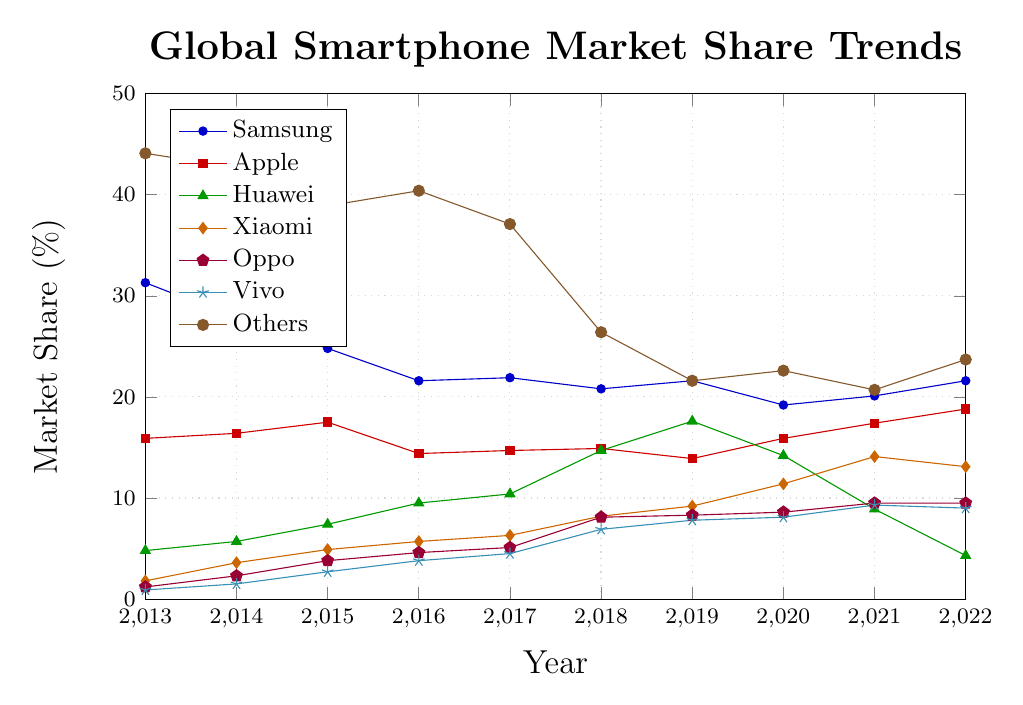Which manufacturer had the highest market share in 2013? To find the manufacturer with the highest market share in 2013, compare the values of all manufacturers in that year. The highest value is 44.1%, which belongs to "Others".
Answer: Others Which manufacturer’s market share increased the most from 2013 to 2022? To determine which manufacturer saw the largest increase, calculate the difference in market share from 2013 to 2022 for each manufacturer. The differences are: Samsung (-9.7), Apple (+2.9), Huawei (-0.5), Xiaomi (+11.3), Oppo (+8.3), Vivo (+8.1), Others (-20.4). Xiaomi's increase of +11.3 is the highest.
Answer: Xiaomi Which year's data shows the smallest market share difference between Samsung and Apple? To find the smallest difference between Samsung and Apple, subtract Apple's market share from Samsung's for each year and find the minimum. The smallest differences are: 2013 (15.4), 2014 (11.4), 2015 (7.3), 2016 (7.2), 2017 (7.2), 2018 (5.9), 2019 (7.7), 2020 (3.3), 2021 (2.7), 2022 (2.8). The smallest difference is in 2021.
Answer: 2021 What is the average market share of Vivo from 2013 to 2022? To find the average market share, sum Vivo's market shares from each year and divide by the number of years: (0.9+1.5+2.7+3.8+4.5+6.9+7.8+8.1+9.3+9.0) = 54.5. Then, divide by 10 years: 54.5/10 = 5.45.
Answer: 5.45% Which manufacturer had a market share of exactly 14.7% at any point in time? Check the data to see if any manufacturer had a market share of 14.7% at any year. Huawei had 14.7% in 2018.
Answer: Huawei How did Apple's market share trend differ from Huawei's between 2018 and 2022? To compare, observe the trend lines of Apple and Huawei from 2018 to 2022. Apple's share increased from 14.9% to 18.8%, while Huawei's decreased from 14.7% to 4.3%. Apple’s market share rose, whereas Huawei’s fell sharply.
Answer: Apple's increased, Huawei's decreased In which year did Xiaomi surpass Huawei in market share? To see when Xiaomi surpassed Huawei, compare their shares each year. Xiaomi surpassed Huawei in 2021 (Xiaomi: 14.1%, Huawei: 8.9%).
Answer: 2021 Compare Samsung’s highest market share year with Apple's highest market share year. Which brand had a higher peak value? Find the peak values for both. Samsung’s highest market share was 31.3% in 2013. Apple’s peak was 18.8% in 2022. Samsung’s peak (31.3%) was higher than Apple’s peak (18.8%).
Answer: Samsung What was the combined market share of Oppo and Vivo in 2018? To find the combined share, add Oppo's and Vivo's market shares for 2018: 8.1 + 6.9 = 15.0%.
Answer: 15.0% Which manufacturer experienced the largest drop in market share from one year to the next, and what years did this occur? Calculate year-to-year changes for each manufacturer. Huawei dropped from 17.6% in 2019 to 14.2% in 2020, a decrease of 3.4%. Check for larger drops among all data points and years. Huawei’s drop from 17.6% to 14.2% in 2019-2020 is the largest drop.
Answer: Huawei, 2019-2020 